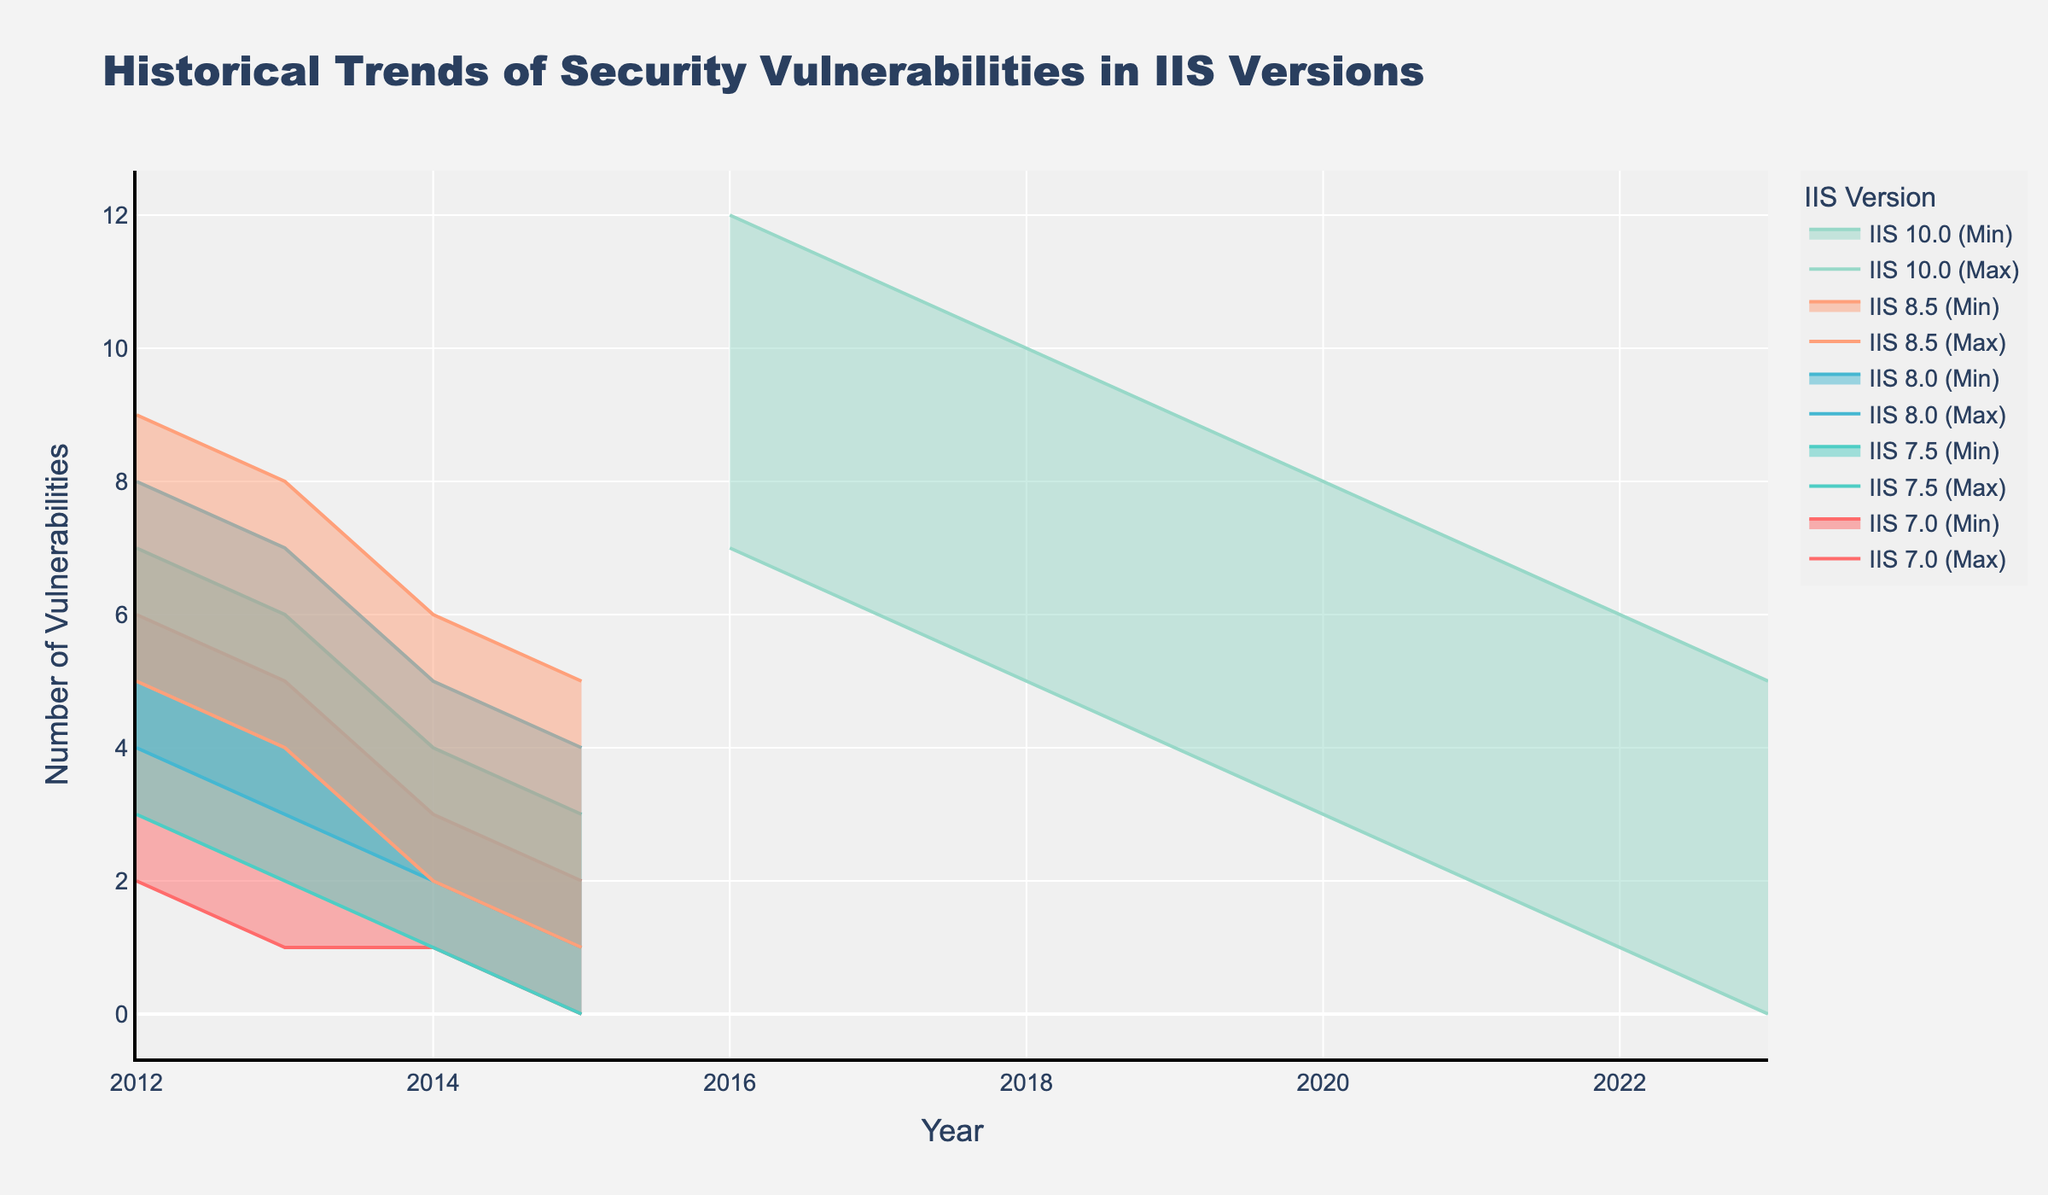What's the title of the chart? The title is usually displayed at the top of the chart and provides a summary of the content. Here, the title can be seen at the top, stating the overall theme of the chart.
Answer: Historical Trends of Security Vulnerabilities in IIS Versions What are the axes titles in the chart? Axes titles help in understanding what each axis represents. In this case, the x-axis title is at the bottom and the y-axis title is on the left side.
Answer: Year (x-axis), Number of Vulnerabilities (y-axis) What is the range of vulnerabilities reported for IIS 10.0 in 2016? To find the range, look for the minimum and maximum vulnerabilities reported for IIS 10.0 in the year 2016 in the chart.
Answer: 7 to 12 How did the maximum number of vulnerabilities in IIS 7.0 change from 2012 to 2015? Examine the maximum vulnerability line for IIS 7.0 and note the values at 2012 and 2015.
Answer: Decreased from 6 to 2 Which IIS version had the highest minimum vulnerabilities reported in a single year, and what was that value? Compare the minimum values of vulnerabilities across all IIS versions for each year to find the highest one.
Answer: IIS 10.0, with a minimum of 7 vulnerabilities in 2016 Compare the vulnerability trends between IIS 8.5 and IIS 10.0 from 2012 to 2015. Examine the trends for both IIS 8.5 and IIS 10.0 in terms of their minimum and maximum vulnerabilities reported during this period.
Answer: IIS 8.5 dropped from 5-9 to 1-5, while IIS 10.0 started in 2016, so no data for 2012-2015 What's the average number of maximum vulnerabilities for IIS 8.5 between 2012 and 2015? Add the maximum vulnerability values for each year between 2012 and 2015 and divide by the number of years.
Answer: (9 + 8 + 6 + 5) / 4 = 7 When did IIS 7.5 have the smallest range of reported vulnerabilities? The range is the difference between the maximum and minimum vulnerabilities. Check each year for IIS 7.5 and find the smallest range.
Answer: 2015, with a range of 3 (3 - 0) Compare the trends of minimum vulnerabilities between IIS 7.0 and IIS 8.0 over the years. Analyze the minimum values reported for IIS 7.0 and IIS 8.0, noting any increases or decreases over the years.
Answer: Both IIS 7.0 and IIS 8.0 show a decreasing trend Which IIS version ended with the fewest vulnerabilities in 2023? Look at the minimum and maximum vulnerabilities reported for each IIS version in 2023.
Answer: IIS 10.0 with a range of 0 to 5 